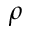Convert formula to latex. <formula><loc_0><loc_0><loc_500><loc_500>\rho</formula> 